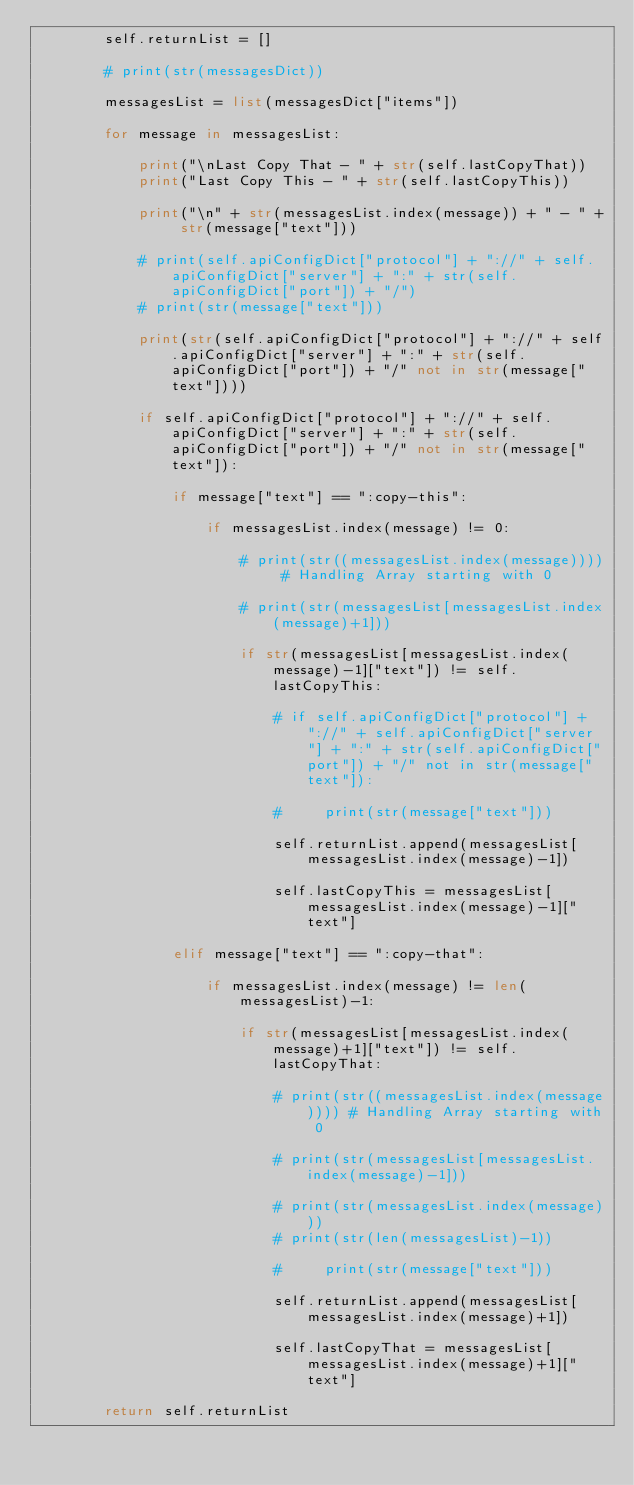Convert code to text. <code><loc_0><loc_0><loc_500><loc_500><_Python_>        self.returnList = []

        # print(str(messagesDict))

        messagesList = list(messagesDict["items"])

        for message in messagesList:

            print("\nLast Copy That - " + str(self.lastCopyThat))
            print("Last Copy This - " + str(self.lastCopyThis))

            print("\n" + str(messagesList.index(message)) + " - " + str(message["text"]))

            # print(self.apiConfigDict["protocol"] + "://" + self.apiConfigDict["server"] + ":" + str(self.apiConfigDict["port"]) + "/")
            # print(str(message["text"]))

            print(str(self.apiConfigDict["protocol"] + "://" + self.apiConfigDict["server"] + ":" + str(self.apiConfigDict["port"]) + "/" not in str(message["text"])))

            if self.apiConfigDict["protocol"] + "://" + self.apiConfigDict["server"] + ":" + str(self.apiConfigDict["port"]) + "/" not in str(message["text"]):

                if message["text"] == ":copy-this":
                    
                    if messagesList.index(message) != 0:

                        # print(str((messagesList.index(message)))) # Handling Array starting with 0

                        # print(str(messagesList[messagesList.index(message)+1]))                                    

                        if str(messagesList[messagesList.index(message)-1]["text"]) != self.lastCopyThis:             

                            # if self.apiConfigDict["protocol"] + "://" + self.apiConfigDict["server"] + ":" + str(self.apiConfigDict["port"]) + "/" not in str(message["text"]):

                            #     print(str(message["text"]))

                            self.returnList.append(messagesList[messagesList.index(message)-1])
                            
                            self.lastCopyThis = messagesList[messagesList.index(message)-1]["text"]

                elif message["text"] == ":copy-that":
                    
                    if messagesList.index(message) != len(messagesList)-1:

                        if str(messagesList[messagesList.index(message)+1]["text"]) != self.lastCopyThat:         

                            # print(str((messagesList.index(message)))) # Handling Array starting with 0

                            # print(str(messagesList[messagesList.index(message)-1]))

                            # print(str(messagesList.index(message)))
                            # print(str(len(messagesList)-1))                    
                            
                            #     print(str(message["text"]))

                            self.returnList.append(messagesList[messagesList.index(message)+1])

                            self.lastCopyThat = messagesList[messagesList.index(message)+1]["text"]

        return self.returnList

</code> 